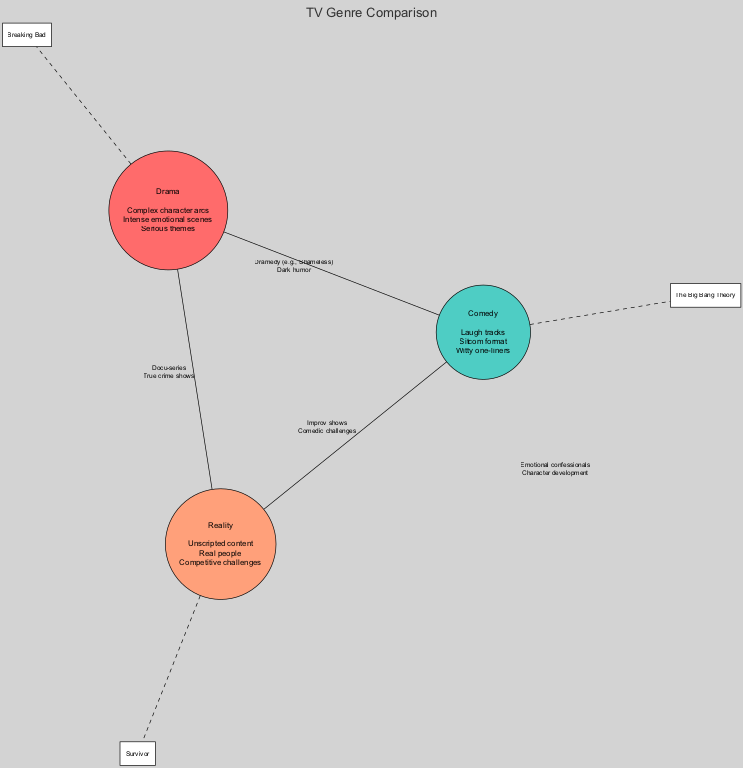What are the elements of the Drama circle? The Drama circle contains three elements: "Complex character arcs," "Intense emotional scenes," and "Serious themes." These can be found listed within the Drama circle in the diagram.
Answer: Complex character arcs, Intense emotional scenes, Serious themes How many overlaps are there in the diagram? The diagram shows four overlaps: between Drama and Comedy, Comedy and Reality, Drama and Reality, and the overlap among all three genres. By counting these overlaps, we confirm there are four.
Answer: 4 What genre includes the show "The Big Bang Theory"? The show "The Big Bang Theory" is categorized under the Comedy genre. This information is presented next to the Comedy circle in the diagram.
Answer: Comedy What common element is shared across Drama, Comedy, and Reality? The common element shared among Drama, Comedy, and Reality is "Emotional confessionals" and "Character development." These are listed at the center of the diagram where all three circles overlap.
Answer: Emotional confessionals, Character development What is a characteristic of Dramedy? A characteristic of Dramedy, which overlaps between Drama and Comedy, is "Dark humor." This element can be found in the overlap section between the Drama and Comedy circles.
Answer: Dark humor How many examples are given for each genre? Each genre in the diagram has one example listed: Drama has "Breaking Bad," Comedy has "The Big Bang Theory," and Reality has "Survivor." Three examples total, one for each genre.
Answer: 1 Which two genres overlap with "Comedic challenges"? "Comedic challenges" overlap between Comedy and Reality genres. This is found in the section where the Comedy and Reality circles intersect.
Answer: Comedy, Reality What type of content does the Reality genre include? The Reality genre includes "Unscripted content" as one of its defining elements. This content is stated within the Reality circle of the diagram.
Answer: Unscripted content 